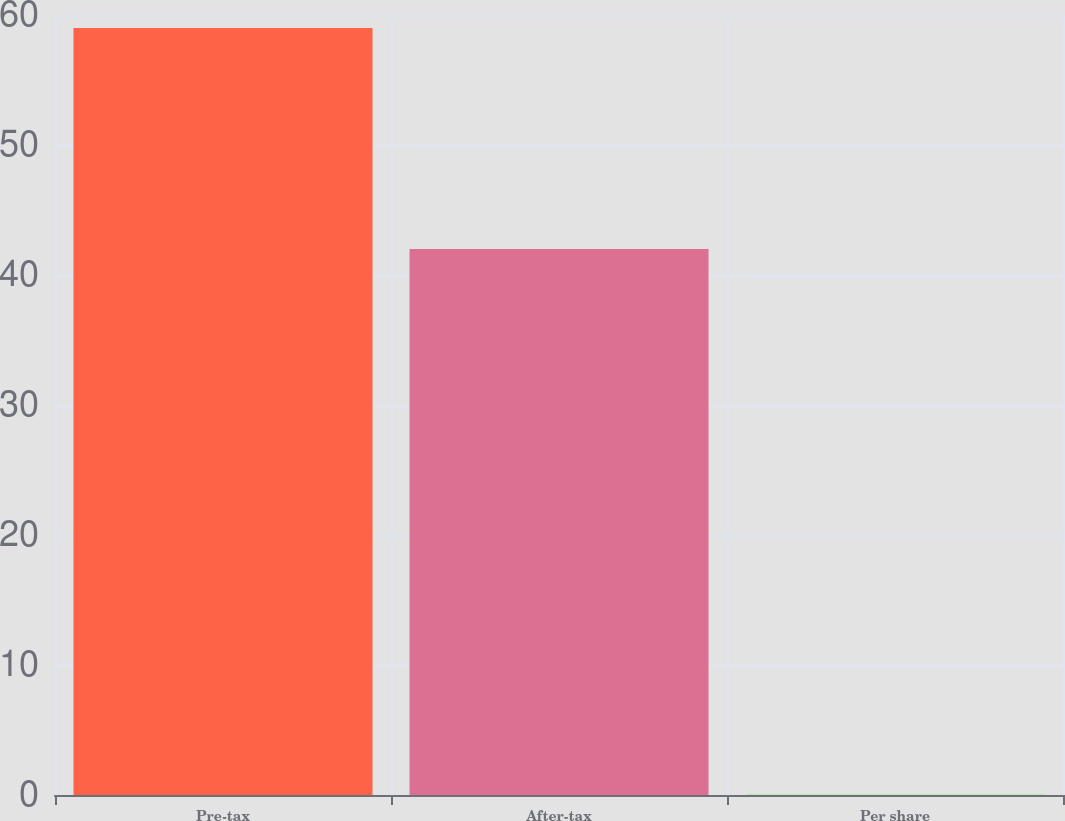Convert chart to OTSL. <chart><loc_0><loc_0><loc_500><loc_500><bar_chart><fcel>Pre-tax<fcel>After-tax<fcel>Per share<nl><fcel>59<fcel>42<fcel>0.02<nl></chart> 